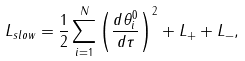<formula> <loc_0><loc_0><loc_500><loc_500>L _ { s l o w } = \frac { 1 } { 2 } \sum _ { i = 1 } ^ { N } \left ( \frac { d \theta _ { i } ^ { 0 } } { d \tau } \right ) ^ { 2 } + L _ { + } + L _ { - } ,</formula> 